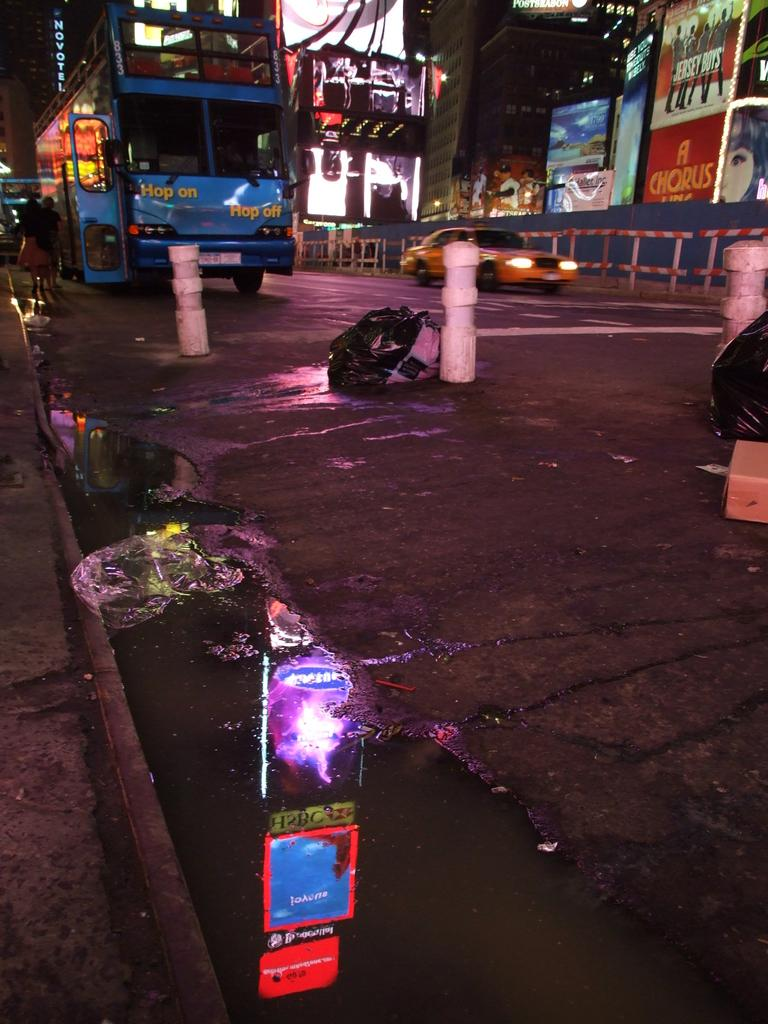What is the main feature of the image? There is a road in the image. What can be seen on the road? There are vehicles on the road. What structures are present along the road? There are poles along the road. What can be seen in the background of the image? There are shops in the background of the image. Where is the mine located in the image? There is no mine present in the image. What type of gun can be seen in the hands of the drivers in the image? There are no guns visible in the image; it only shows vehicles on the road. 